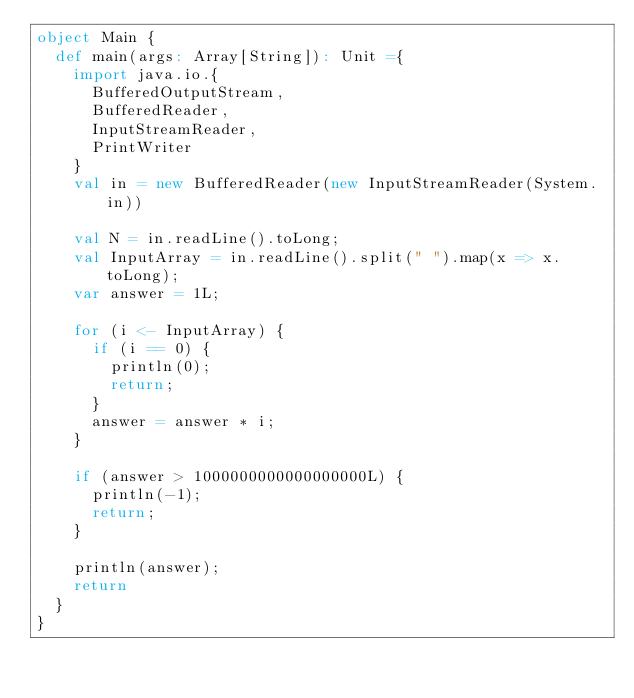<code> <loc_0><loc_0><loc_500><loc_500><_Scala_>object Main {
  def main(args: Array[String]): Unit ={
    import java.io.{
      BufferedOutputStream,
      BufferedReader,
      InputStreamReader,
      PrintWriter
    }
    val in = new BufferedReader(new InputStreamReader(System.in))

    val N = in.readLine().toLong;
    val InputArray = in.readLine().split(" ").map(x => x.toLong);
    var answer = 1L;

    for (i <- InputArray) {
      if (i == 0) {
        println(0);
        return;
      }
      answer = answer * i;
    }

    if (answer > 1000000000000000000L) {
      println(-1);
      return;
    }

    println(answer);
    return
  }
}
</code> 